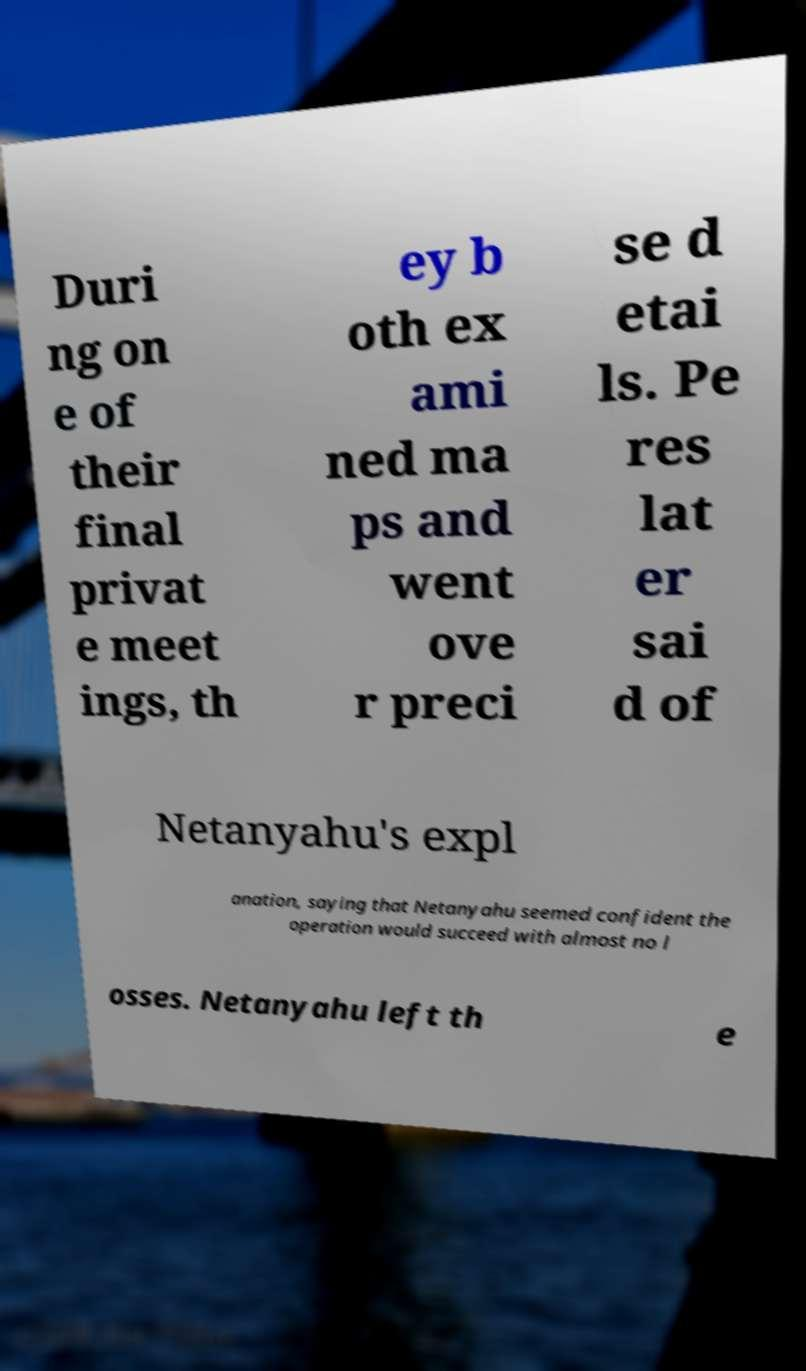Could you extract and type out the text from this image? Duri ng on e of their final privat e meet ings, th ey b oth ex ami ned ma ps and went ove r preci se d etai ls. Pe res lat er sai d of Netanyahu's expl anation, saying that Netanyahu seemed confident the operation would succeed with almost no l osses. Netanyahu left th e 